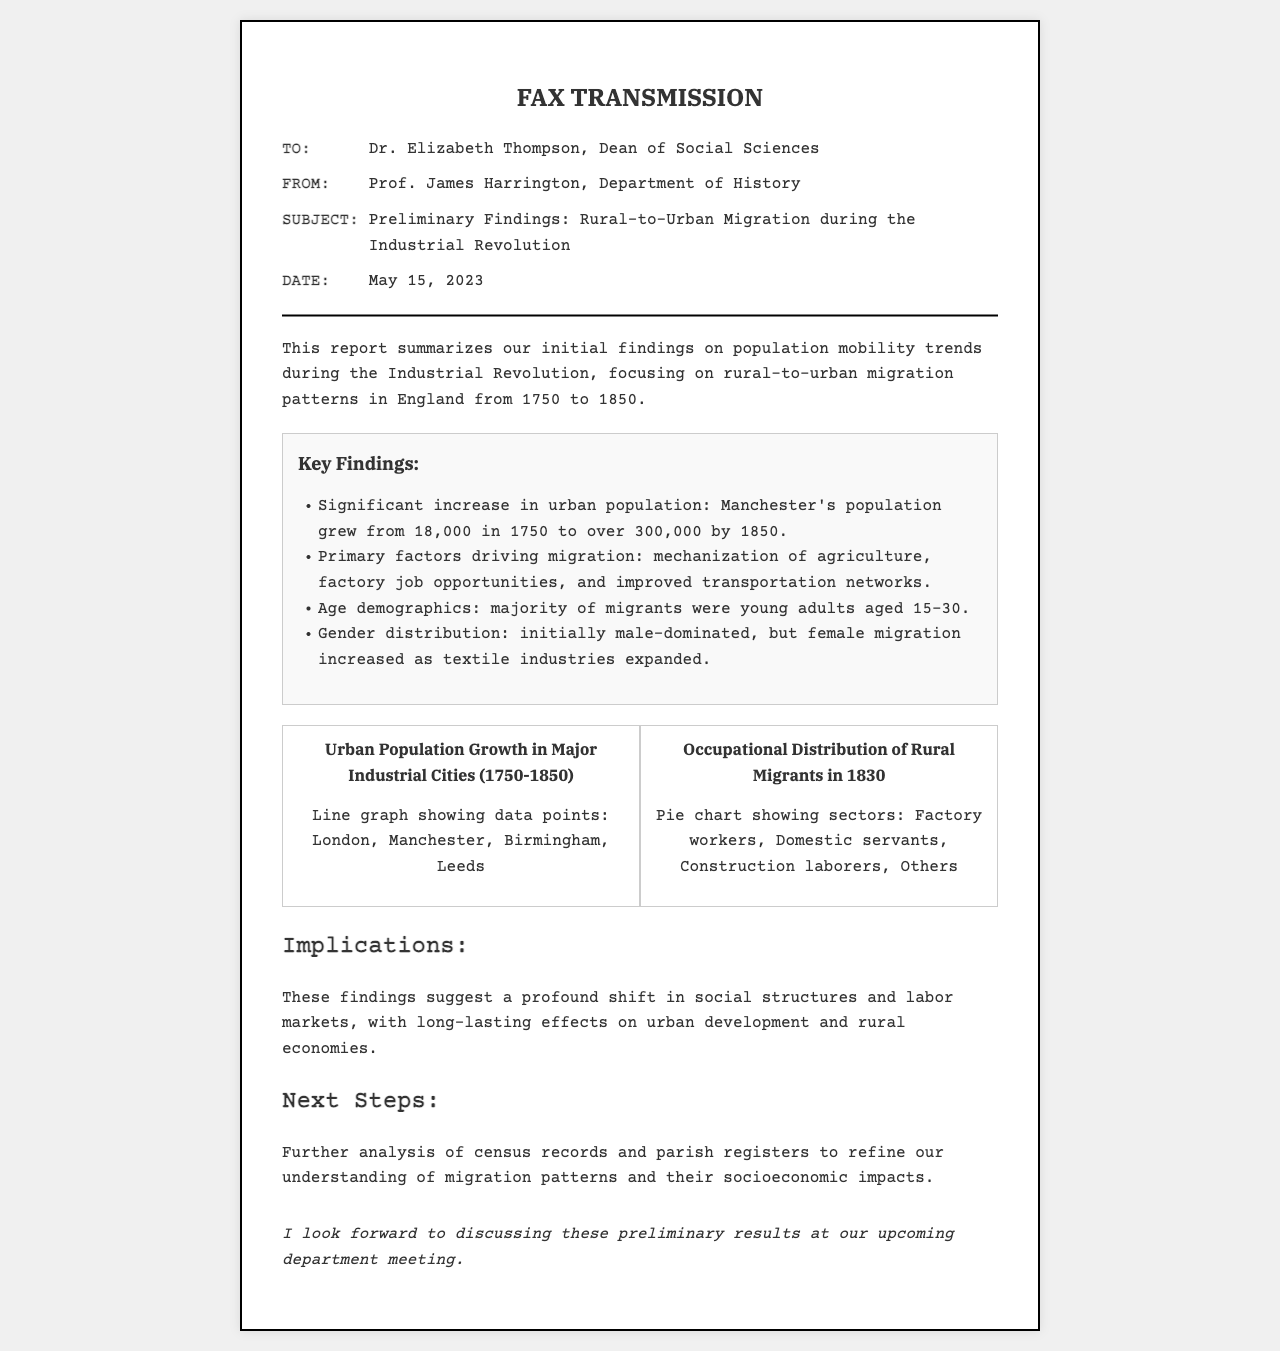what is the date of the fax? The date is mentioned in the header section of the fax as May 15, 2023.
Answer: May 15, 2023 who is the sender of the fax? The sender's name is provided in the header section as Prof. James Harrington.
Answer: Prof. James Harrington which city saw a population growth from 18,000 to over 300,000? This specific detail about population growth is highlighted as Manchester's growth during the stated period.
Answer: Manchester what demographic age group comprised the majority of rural-to-urban migrants? The document specifies that the majority of migrants were young adults aged 15-30.
Answer: young adults aged 15-30 what was the primary factor driving migration according to the report? The report lists mechanization of agriculture as one of the primary factors driving rural-to-urban migration.
Answer: mechanization of agriculture how many major industrial cities are mentioned in the urban population growth chart? The document refers to four major cities: London, Manchester, Birmingham, and Leeds in the chart heading.
Answer: four what type of chart is used to represent occupational distribution of rural migrants? The document clearly states that a pie chart is used for this purpose in the summary.
Answer: pie chart what will the next steps involve according to the report? The report states that the next steps will involve further analysis of census records.
Answer: further analysis of census records what is implied by the findings regarding social structures? The report suggests a profound shift in social structures and labor markets due to the migration trends noted.
Answer: profound shift in social structures 